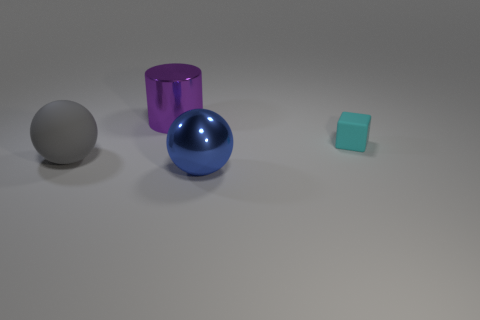What color is the large metallic ball?
Offer a terse response. Blue. How many objects are either matte balls or large brown cubes?
Your answer should be compact. 1. There is a gray thing that is the same size as the purple cylinder; what material is it?
Your response must be concise. Rubber. There is a matte thing that is right of the large purple thing; how big is it?
Offer a very short reply. Small. What is the material of the large purple object?
Your answer should be compact. Metal. How many objects are either rubber objects on the right side of the large blue metallic sphere or large balls behind the blue metal ball?
Offer a very short reply. 2. How many other things are there of the same color as the cube?
Provide a succinct answer. 0. There is a big blue metal thing; is its shape the same as the big thing that is left of the big cylinder?
Provide a succinct answer. Yes. Is the number of large purple shiny cylinders on the right side of the purple shiny object less than the number of gray rubber objects that are in front of the blue ball?
Your response must be concise. No. There is a blue thing that is the same shape as the gray thing; what material is it?
Ensure brevity in your answer.  Metal. 